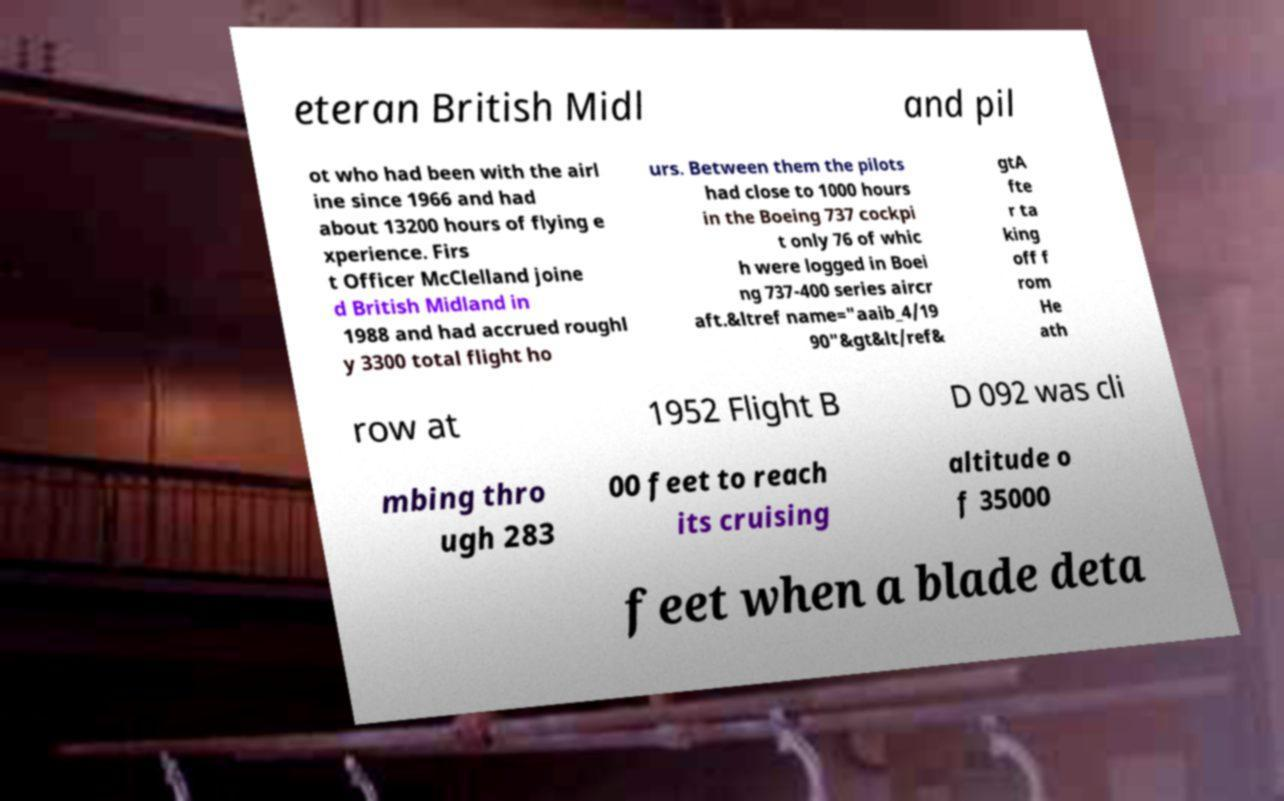Can you read and provide the text displayed in the image?This photo seems to have some interesting text. Can you extract and type it out for me? eteran British Midl and pil ot who had been with the airl ine since 1966 and had about 13200 hours of flying e xperience. Firs t Officer McClelland joine d British Midland in 1988 and had accrued roughl y 3300 total flight ho urs. Between them the pilots had close to 1000 hours in the Boeing 737 cockpi t only 76 of whic h were logged in Boei ng 737-400 series aircr aft.&ltref name="aaib_4/19 90"&gt&lt/ref& gtA fte r ta king off f rom He ath row at 1952 Flight B D 092 was cli mbing thro ugh 283 00 feet to reach its cruising altitude o f 35000 feet when a blade deta 